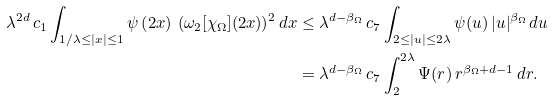<formula> <loc_0><loc_0><loc_500><loc_500>\lambda ^ { 2 d } \, c _ { 1 } \int _ { 1 / \lambda \leq | x | \leq 1 } \psi \left ( 2 x \right ) \, ( \omega _ { 2 } [ \chi _ { \Omega } ] ( 2 x ) ) ^ { 2 } \, d x & \leq \lambda ^ { d - \beta _ { \Omega } } \, c _ { 7 } \int _ { 2 \leq | u | \leq 2 \lambda } \psi ( u ) \, | u | ^ { \beta _ { \Omega } } \, d u \\ & = \lambda ^ { d - \beta _ { \Omega } } \, c _ { 7 } \int _ { 2 } ^ { 2 \lambda } \Psi ( r ) \, r ^ { \beta _ { \Omega } + d - 1 } \, d r .</formula> 